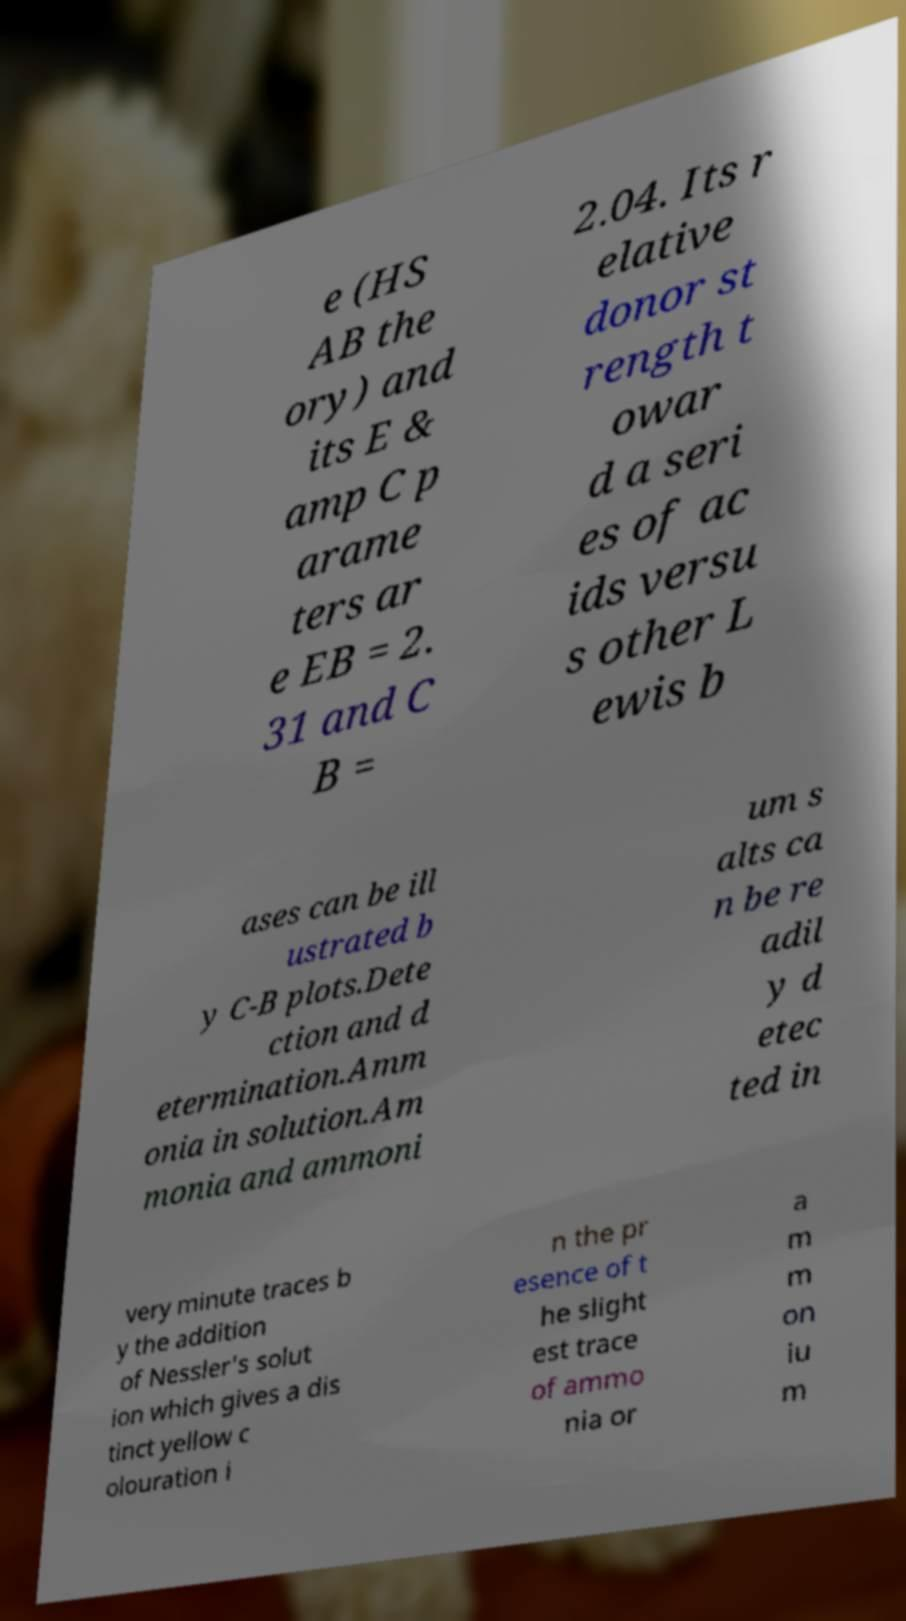Please identify and transcribe the text found in this image. e (HS AB the ory) and its E & amp C p arame ters ar e EB = 2. 31 and C B = 2.04. Its r elative donor st rength t owar d a seri es of ac ids versu s other L ewis b ases can be ill ustrated b y C-B plots.Dete ction and d etermination.Amm onia in solution.Am monia and ammoni um s alts ca n be re adil y d etec ted in very minute traces b y the addition of Nessler's solut ion which gives a dis tinct yellow c olouration i n the pr esence of t he slight est trace of ammo nia or a m m on iu m 